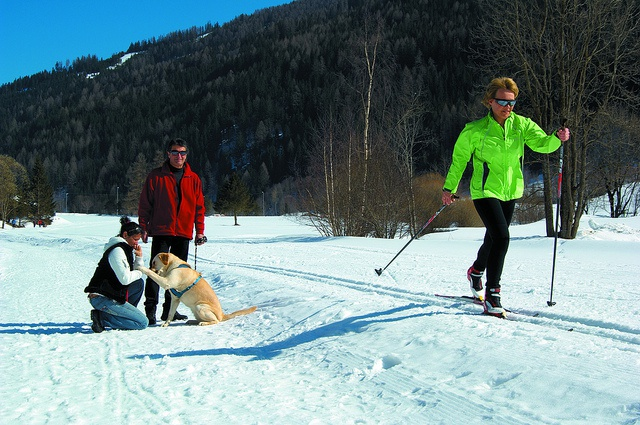Describe the objects in this image and their specific colors. I can see people in gray, black, lime, green, and lightgreen tones, people in gray, black, maroon, and red tones, people in gray, black, blue, ivory, and teal tones, dog in gray, tan, and darkgray tones, and skis in gray and darkgray tones in this image. 